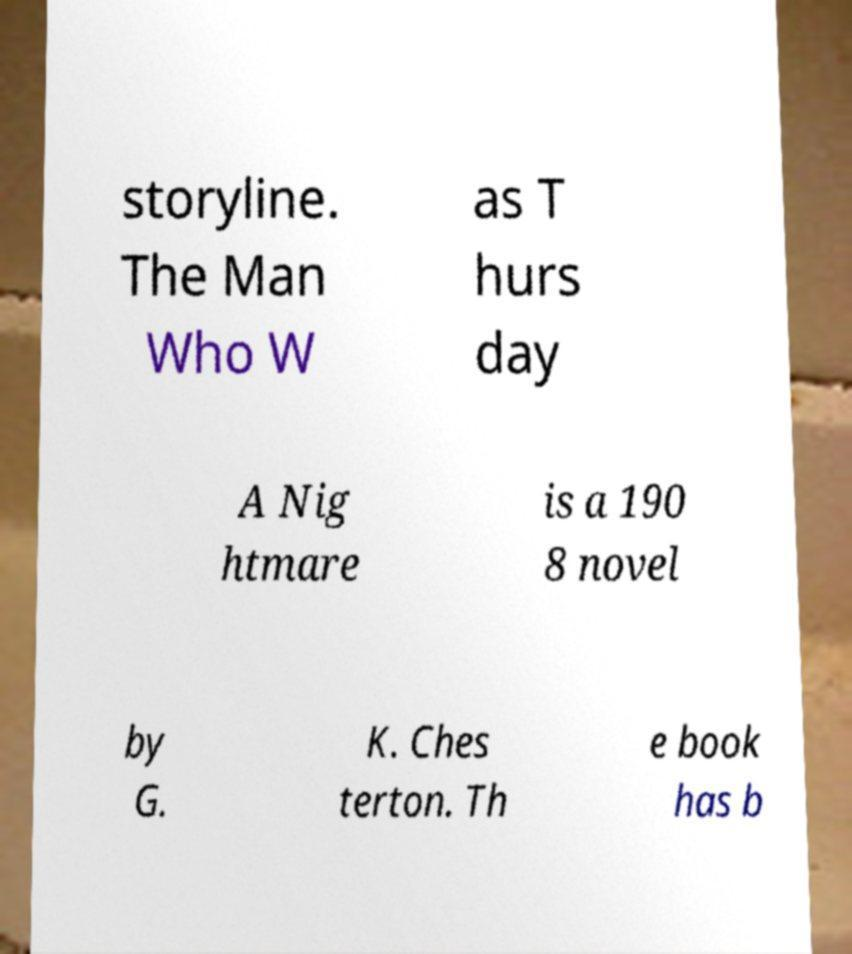Can you accurately transcribe the text from the provided image for me? storyline. The Man Who W as T hurs day A Nig htmare is a 190 8 novel by G. K. Ches terton. Th e book has b 